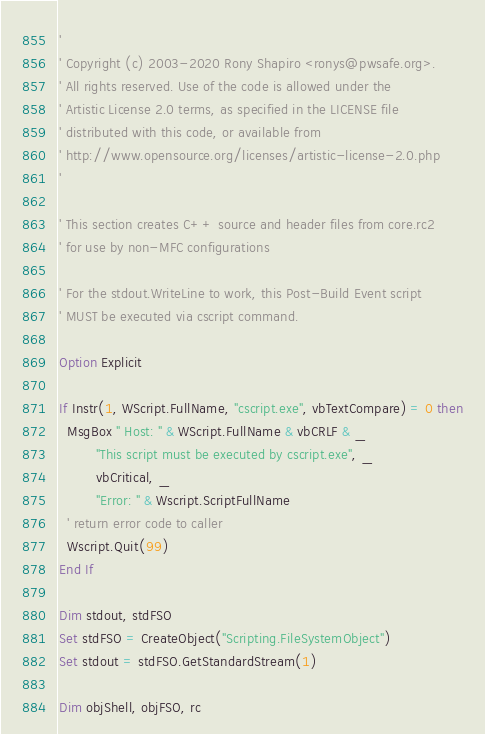<code> <loc_0><loc_0><loc_500><loc_500><_VisualBasic_>'
' Copyright (c) 2003-2020 Rony Shapiro <ronys@pwsafe.org>.
' All rights reserved. Use of the code is allowed under the
' Artistic License 2.0 terms, as specified in the LICENSE file
' distributed with this code, or available from
' http://www.opensource.org/licenses/artistic-license-2.0.php
'

' This section creates C++ source and header files from core.rc2
' for use by non-MFC configurations

' For the stdout.WriteLine to work, this Post-Build Event script
' MUST be executed via cscript command.

Option Explicit

If Instr(1, WScript.FullName, "cscript.exe", vbTextCompare) = 0 then
  MsgBox " Host: " & WScript.FullName & vbCRLF & _
         "This script must be executed by cscript.exe", _
         vbCritical, _
         "Error: " & Wscript.ScriptFullName
  ' return error code to caller
  Wscript.Quit(99)
End If

Dim stdout, stdFSO
Set stdFSO = CreateObject("Scripting.FileSystemObject")
Set stdout = stdFSO.GetStandardStream(1)

Dim objShell, objFSO, rc</code> 